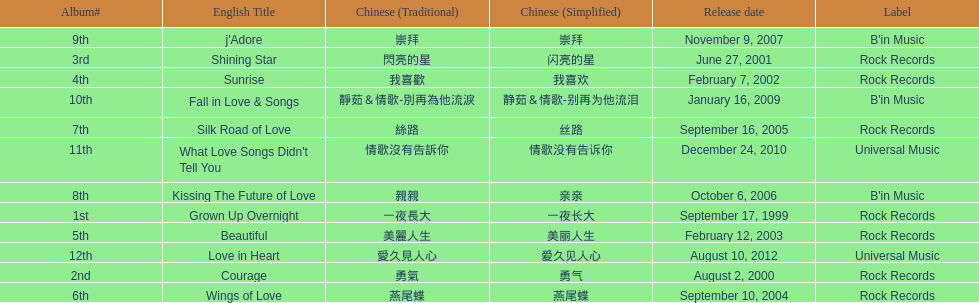What is the number of songs on rock records? 7. 